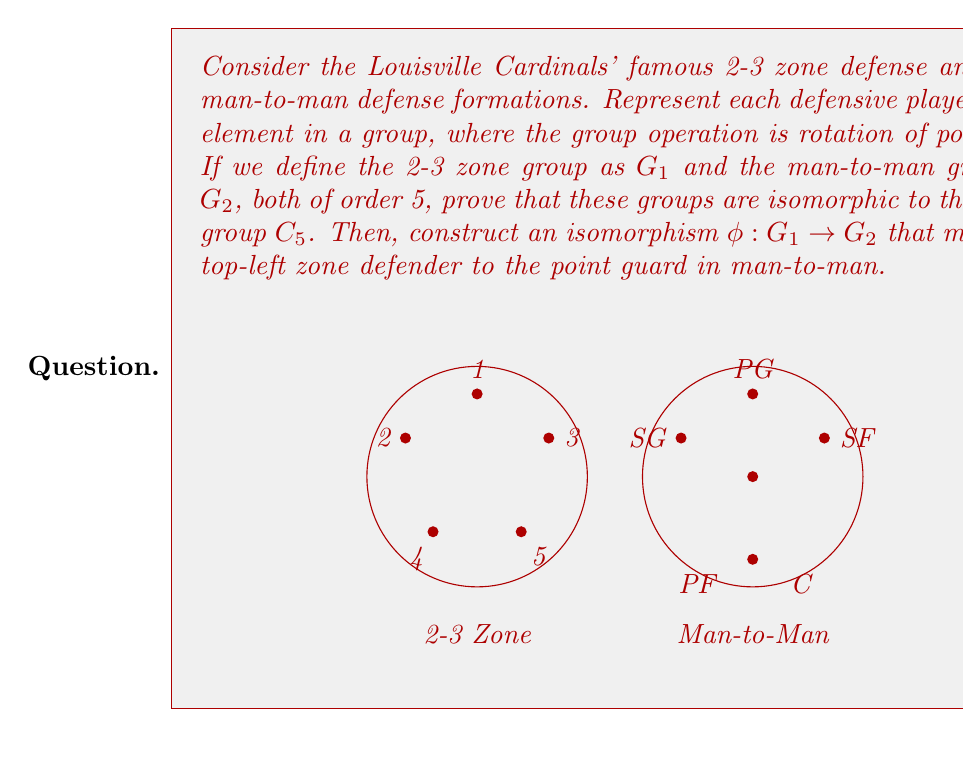Solve this math problem. Let's approach this step-by-step:

1) First, we need to show that both $G_1$ and $G_2$ are isomorphic to $C_5$. 

2) For $G_1$ (2-3 zone):
   - Label the positions 1, 2, 3, 4, 5 as shown in the diagram.
   - The rotation operation moves each player to the next position: 1→2→3→4→5→1.
   - This forms a cyclic group of order 5, which is isomorphic to $C_5$.

3) For $G_2$ (man-to-man):
   - Label the positions PG, SG, SF, PF, C.
   - Similarly, we can define a rotation: PG→SG→SF→PF→C→PG.
   - This also forms a cyclic group of order 5, isomorphic to $C_5$.

4) Since both $G_1$ and $G_2$ are isomorphic to $C_5$, they are isomorphic to each other.

5) To construct an isomorphism $\phi: G_1 \to G_2$ mapping the top-left zone defender (1) to the point guard (PG):
   - Define $\phi(1) = PG$
   - Then, $\phi(2) = SG$, $\phi(3) = SF$, $\phi(4) = PF$, $\phi(5) = C$

6) We can represent this isomorphism as:
   $$\phi = \begin{pmatrix} 
   1 & 2 & 3 & 4 & 5 \\
   PG & SG & SF & PF & C
   \end{pmatrix}$$

7) To verify this is an isomorphism:
   - Check that it's bijective (one-to-one and onto): clear from the construction.
   - Check that it preserves the group operation (rotation):
     $\phi(1 \circ 2) = \phi(3) = SF = PG \circ SG = \phi(1) \circ \phi(2)$
     (where $\circ$ represents the rotation operation in each group)

Thus, we have constructed an isomorphism between the 2-3 zone and man-to-man defensive formations, demonstrating their structural equivalence in terms of rotations.
Answer: $\phi = \begin{pmatrix} 
1 & 2 & 3 & 4 & 5 \\
PG & SG & SF & PF & C
\end{pmatrix}$ 